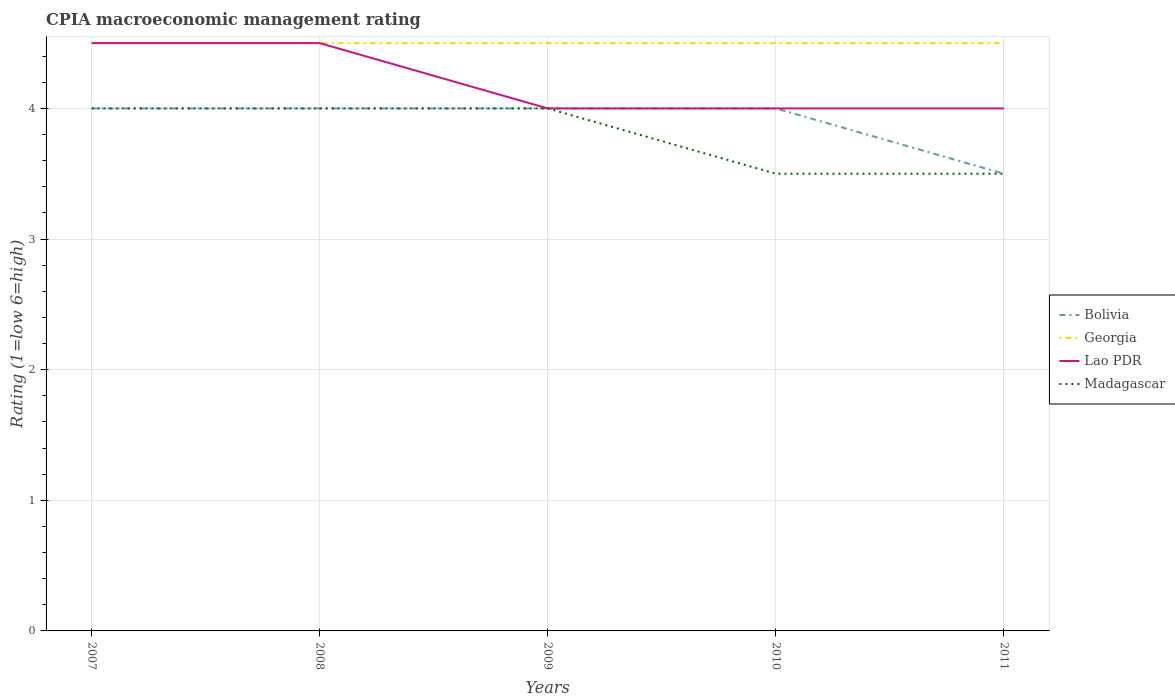Is the number of lines equal to the number of legend labels?
Provide a succinct answer. Yes. Across all years, what is the maximum CPIA rating in Bolivia?
Offer a terse response. 3.5. In which year was the CPIA rating in Madagascar maximum?
Keep it short and to the point. 2010. What is the total CPIA rating in Bolivia in the graph?
Your response must be concise. 0. How many lines are there?
Your answer should be very brief. 4. How many years are there in the graph?
Provide a short and direct response. 5. What is the difference between two consecutive major ticks on the Y-axis?
Offer a terse response. 1. Are the values on the major ticks of Y-axis written in scientific E-notation?
Your response must be concise. No. Where does the legend appear in the graph?
Make the answer very short. Center right. How many legend labels are there?
Your answer should be compact. 4. How are the legend labels stacked?
Keep it short and to the point. Vertical. What is the title of the graph?
Your answer should be very brief. CPIA macroeconomic management rating. What is the label or title of the Y-axis?
Your answer should be compact. Rating (1=low 6=high). What is the Rating (1=low 6=high) in Bolivia in 2007?
Your answer should be very brief. 4. What is the Rating (1=low 6=high) of Georgia in 2007?
Provide a short and direct response. 4.5. What is the Rating (1=low 6=high) of Lao PDR in 2007?
Ensure brevity in your answer.  4.5. What is the Rating (1=low 6=high) of Madagascar in 2007?
Your answer should be compact. 4. What is the Rating (1=low 6=high) in Bolivia in 2008?
Keep it short and to the point. 4. What is the Rating (1=low 6=high) in Georgia in 2009?
Offer a very short reply. 4.5. What is the Rating (1=low 6=high) of Madagascar in 2009?
Make the answer very short. 4. What is the Rating (1=low 6=high) of Bolivia in 2010?
Ensure brevity in your answer.  4. What is the Rating (1=low 6=high) in Lao PDR in 2010?
Provide a short and direct response. 4. What is the Rating (1=low 6=high) in Madagascar in 2010?
Offer a very short reply. 3.5. What is the Rating (1=low 6=high) in Bolivia in 2011?
Offer a very short reply. 3.5. What is the Rating (1=low 6=high) of Georgia in 2011?
Provide a succinct answer. 4.5. What is the Rating (1=low 6=high) of Lao PDR in 2011?
Ensure brevity in your answer.  4. What is the Rating (1=low 6=high) of Madagascar in 2011?
Your response must be concise. 3.5. Across all years, what is the maximum Rating (1=low 6=high) of Bolivia?
Keep it short and to the point. 4. Across all years, what is the maximum Rating (1=low 6=high) of Georgia?
Your answer should be compact. 4.5. What is the total Rating (1=low 6=high) in Georgia in the graph?
Provide a short and direct response. 22.5. What is the total Rating (1=low 6=high) in Madagascar in the graph?
Provide a succinct answer. 19. What is the difference between the Rating (1=low 6=high) of Bolivia in 2007 and that in 2009?
Offer a very short reply. 0. What is the difference between the Rating (1=low 6=high) of Madagascar in 2007 and that in 2010?
Provide a short and direct response. 0.5. What is the difference between the Rating (1=low 6=high) in Bolivia in 2007 and that in 2011?
Offer a terse response. 0.5. What is the difference between the Rating (1=low 6=high) in Georgia in 2007 and that in 2011?
Keep it short and to the point. 0. What is the difference between the Rating (1=low 6=high) in Madagascar in 2007 and that in 2011?
Your answer should be very brief. 0.5. What is the difference between the Rating (1=low 6=high) of Lao PDR in 2008 and that in 2009?
Your response must be concise. 0.5. What is the difference between the Rating (1=low 6=high) of Madagascar in 2008 and that in 2009?
Your answer should be compact. 0. What is the difference between the Rating (1=low 6=high) in Bolivia in 2008 and that in 2011?
Make the answer very short. 0.5. What is the difference between the Rating (1=low 6=high) of Georgia in 2008 and that in 2011?
Give a very brief answer. 0. What is the difference between the Rating (1=low 6=high) in Lao PDR in 2008 and that in 2011?
Offer a very short reply. 0.5. What is the difference between the Rating (1=low 6=high) of Madagascar in 2008 and that in 2011?
Make the answer very short. 0.5. What is the difference between the Rating (1=low 6=high) in Georgia in 2009 and that in 2010?
Your response must be concise. 0. What is the difference between the Rating (1=low 6=high) in Lao PDR in 2009 and that in 2010?
Give a very brief answer. 0. What is the difference between the Rating (1=low 6=high) in Madagascar in 2009 and that in 2010?
Offer a terse response. 0.5. What is the difference between the Rating (1=low 6=high) in Bolivia in 2009 and that in 2011?
Your answer should be compact. 0.5. What is the difference between the Rating (1=low 6=high) in Madagascar in 2009 and that in 2011?
Your answer should be very brief. 0.5. What is the difference between the Rating (1=low 6=high) of Madagascar in 2010 and that in 2011?
Provide a succinct answer. 0. What is the difference between the Rating (1=low 6=high) of Bolivia in 2007 and the Rating (1=low 6=high) of Georgia in 2008?
Make the answer very short. -0.5. What is the difference between the Rating (1=low 6=high) in Bolivia in 2007 and the Rating (1=low 6=high) in Lao PDR in 2008?
Offer a very short reply. -0.5. What is the difference between the Rating (1=low 6=high) of Georgia in 2007 and the Rating (1=low 6=high) of Madagascar in 2008?
Keep it short and to the point. 0.5. What is the difference between the Rating (1=low 6=high) of Bolivia in 2007 and the Rating (1=low 6=high) of Georgia in 2009?
Give a very brief answer. -0.5. What is the difference between the Rating (1=low 6=high) in Bolivia in 2007 and the Rating (1=low 6=high) in Lao PDR in 2009?
Provide a succinct answer. 0. What is the difference between the Rating (1=low 6=high) of Bolivia in 2007 and the Rating (1=low 6=high) of Madagascar in 2009?
Your answer should be compact. 0. What is the difference between the Rating (1=low 6=high) in Lao PDR in 2007 and the Rating (1=low 6=high) in Madagascar in 2009?
Ensure brevity in your answer.  0.5. What is the difference between the Rating (1=low 6=high) of Bolivia in 2007 and the Rating (1=low 6=high) of Georgia in 2010?
Your answer should be very brief. -0.5. What is the difference between the Rating (1=low 6=high) of Georgia in 2007 and the Rating (1=low 6=high) of Lao PDR in 2010?
Offer a very short reply. 0.5. What is the difference between the Rating (1=low 6=high) in Lao PDR in 2007 and the Rating (1=low 6=high) in Madagascar in 2010?
Your answer should be compact. 1. What is the difference between the Rating (1=low 6=high) in Bolivia in 2007 and the Rating (1=low 6=high) in Lao PDR in 2011?
Provide a short and direct response. 0. What is the difference between the Rating (1=low 6=high) of Bolivia in 2007 and the Rating (1=low 6=high) of Madagascar in 2011?
Offer a very short reply. 0.5. What is the difference between the Rating (1=low 6=high) in Georgia in 2007 and the Rating (1=low 6=high) in Lao PDR in 2011?
Offer a very short reply. 0.5. What is the difference between the Rating (1=low 6=high) in Lao PDR in 2007 and the Rating (1=low 6=high) in Madagascar in 2011?
Provide a short and direct response. 1. What is the difference between the Rating (1=low 6=high) of Bolivia in 2008 and the Rating (1=low 6=high) of Georgia in 2009?
Your answer should be compact. -0.5. What is the difference between the Rating (1=low 6=high) in Bolivia in 2008 and the Rating (1=low 6=high) in Georgia in 2010?
Give a very brief answer. -0.5. What is the difference between the Rating (1=low 6=high) in Bolivia in 2008 and the Rating (1=low 6=high) in Madagascar in 2010?
Make the answer very short. 0.5. What is the difference between the Rating (1=low 6=high) of Bolivia in 2008 and the Rating (1=low 6=high) of Georgia in 2011?
Offer a very short reply. -0.5. What is the difference between the Rating (1=low 6=high) in Bolivia in 2008 and the Rating (1=low 6=high) in Lao PDR in 2011?
Your answer should be compact. 0. What is the difference between the Rating (1=low 6=high) in Lao PDR in 2008 and the Rating (1=low 6=high) in Madagascar in 2011?
Provide a short and direct response. 1. What is the difference between the Rating (1=low 6=high) in Bolivia in 2009 and the Rating (1=low 6=high) in Lao PDR in 2010?
Keep it short and to the point. 0. What is the difference between the Rating (1=low 6=high) in Bolivia in 2009 and the Rating (1=low 6=high) in Lao PDR in 2011?
Give a very brief answer. 0. What is the difference between the Rating (1=low 6=high) of Georgia in 2009 and the Rating (1=low 6=high) of Lao PDR in 2011?
Ensure brevity in your answer.  0.5. What is the difference between the Rating (1=low 6=high) in Georgia in 2009 and the Rating (1=low 6=high) in Madagascar in 2011?
Keep it short and to the point. 1. What is the difference between the Rating (1=low 6=high) in Bolivia in 2010 and the Rating (1=low 6=high) in Madagascar in 2011?
Your response must be concise. 0.5. What is the difference between the Rating (1=low 6=high) of Georgia in 2010 and the Rating (1=low 6=high) of Lao PDR in 2011?
Offer a terse response. 0.5. What is the difference between the Rating (1=low 6=high) in Georgia in 2010 and the Rating (1=low 6=high) in Madagascar in 2011?
Your answer should be compact. 1. What is the difference between the Rating (1=low 6=high) of Lao PDR in 2010 and the Rating (1=low 6=high) of Madagascar in 2011?
Offer a terse response. 0.5. What is the average Rating (1=low 6=high) in Georgia per year?
Offer a terse response. 4.5. What is the average Rating (1=low 6=high) of Lao PDR per year?
Your answer should be compact. 4.2. What is the average Rating (1=low 6=high) in Madagascar per year?
Make the answer very short. 3.8. In the year 2007, what is the difference between the Rating (1=low 6=high) in Bolivia and Rating (1=low 6=high) in Georgia?
Provide a short and direct response. -0.5. In the year 2007, what is the difference between the Rating (1=low 6=high) in Georgia and Rating (1=low 6=high) in Madagascar?
Give a very brief answer. 0.5. In the year 2008, what is the difference between the Rating (1=low 6=high) in Bolivia and Rating (1=low 6=high) in Georgia?
Your response must be concise. -0.5. In the year 2008, what is the difference between the Rating (1=low 6=high) in Bolivia and Rating (1=low 6=high) in Lao PDR?
Offer a terse response. -0.5. In the year 2008, what is the difference between the Rating (1=low 6=high) of Georgia and Rating (1=low 6=high) of Lao PDR?
Your response must be concise. 0. In the year 2008, what is the difference between the Rating (1=low 6=high) of Georgia and Rating (1=low 6=high) of Madagascar?
Ensure brevity in your answer.  0.5. In the year 2008, what is the difference between the Rating (1=low 6=high) in Lao PDR and Rating (1=low 6=high) in Madagascar?
Keep it short and to the point. 0.5. In the year 2009, what is the difference between the Rating (1=low 6=high) of Bolivia and Rating (1=low 6=high) of Lao PDR?
Your response must be concise. 0. In the year 2009, what is the difference between the Rating (1=low 6=high) in Bolivia and Rating (1=low 6=high) in Madagascar?
Provide a short and direct response. 0. In the year 2009, what is the difference between the Rating (1=low 6=high) of Georgia and Rating (1=low 6=high) of Madagascar?
Provide a succinct answer. 0.5. In the year 2009, what is the difference between the Rating (1=low 6=high) of Lao PDR and Rating (1=low 6=high) of Madagascar?
Provide a short and direct response. 0. In the year 2010, what is the difference between the Rating (1=low 6=high) in Bolivia and Rating (1=low 6=high) in Georgia?
Make the answer very short. -0.5. In the year 2010, what is the difference between the Rating (1=low 6=high) of Bolivia and Rating (1=low 6=high) of Lao PDR?
Your answer should be very brief. 0. In the year 2010, what is the difference between the Rating (1=low 6=high) in Georgia and Rating (1=low 6=high) in Lao PDR?
Your answer should be compact. 0.5. In the year 2010, what is the difference between the Rating (1=low 6=high) of Georgia and Rating (1=low 6=high) of Madagascar?
Your response must be concise. 1. In the year 2011, what is the difference between the Rating (1=low 6=high) of Georgia and Rating (1=low 6=high) of Madagascar?
Make the answer very short. 1. What is the ratio of the Rating (1=low 6=high) of Bolivia in 2007 to that in 2008?
Ensure brevity in your answer.  1. What is the ratio of the Rating (1=low 6=high) of Georgia in 2007 to that in 2008?
Your answer should be compact. 1. What is the ratio of the Rating (1=low 6=high) in Georgia in 2007 to that in 2010?
Your response must be concise. 1. What is the ratio of the Rating (1=low 6=high) in Madagascar in 2007 to that in 2010?
Your answer should be very brief. 1.14. What is the ratio of the Rating (1=low 6=high) in Bolivia in 2007 to that in 2011?
Offer a terse response. 1.14. What is the ratio of the Rating (1=low 6=high) of Georgia in 2007 to that in 2011?
Your response must be concise. 1. What is the ratio of the Rating (1=low 6=high) in Lao PDR in 2007 to that in 2011?
Offer a terse response. 1.12. What is the ratio of the Rating (1=low 6=high) of Bolivia in 2008 to that in 2009?
Offer a very short reply. 1. What is the ratio of the Rating (1=low 6=high) of Lao PDR in 2008 to that in 2009?
Offer a very short reply. 1.12. What is the ratio of the Rating (1=low 6=high) in Bolivia in 2008 to that in 2010?
Make the answer very short. 1. What is the ratio of the Rating (1=low 6=high) of Georgia in 2008 to that in 2010?
Provide a short and direct response. 1. What is the ratio of the Rating (1=low 6=high) of Madagascar in 2008 to that in 2010?
Keep it short and to the point. 1.14. What is the ratio of the Rating (1=low 6=high) of Bolivia in 2008 to that in 2011?
Keep it short and to the point. 1.14. What is the ratio of the Rating (1=low 6=high) of Lao PDR in 2008 to that in 2011?
Keep it short and to the point. 1.12. What is the ratio of the Rating (1=low 6=high) in Lao PDR in 2009 to that in 2010?
Make the answer very short. 1. What is the ratio of the Rating (1=low 6=high) of Madagascar in 2009 to that in 2011?
Give a very brief answer. 1.14. What is the ratio of the Rating (1=low 6=high) of Bolivia in 2010 to that in 2011?
Give a very brief answer. 1.14. What is the ratio of the Rating (1=low 6=high) of Georgia in 2010 to that in 2011?
Give a very brief answer. 1. What is the ratio of the Rating (1=low 6=high) in Lao PDR in 2010 to that in 2011?
Give a very brief answer. 1. What is the ratio of the Rating (1=low 6=high) in Madagascar in 2010 to that in 2011?
Keep it short and to the point. 1. What is the difference between the highest and the second highest Rating (1=low 6=high) of Georgia?
Keep it short and to the point. 0. What is the difference between the highest and the second highest Rating (1=low 6=high) of Lao PDR?
Provide a short and direct response. 0. What is the difference between the highest and the second highest Rating (1=low 6=high) in Madagascar?
Ensure brevity in your answer.  0. What is the difference between the highest and the lowest Rating (1=low 6=high) in Bolivia?
Offer a terse response. 0.5. What is the difference between the highest and the lowest Rating (1=low 6=high) in Georgia?
Keep it short and to the point. 0. What is the difference between the highest and the lowest Rating (1=low 6=high) in Lao PDR?
Provide a short and direct response. 0.5. What is the difference between the highest and the lowest Rating (1=low 6=high) in Madagascar?
Ensure brevity in your answer.  0.5. 